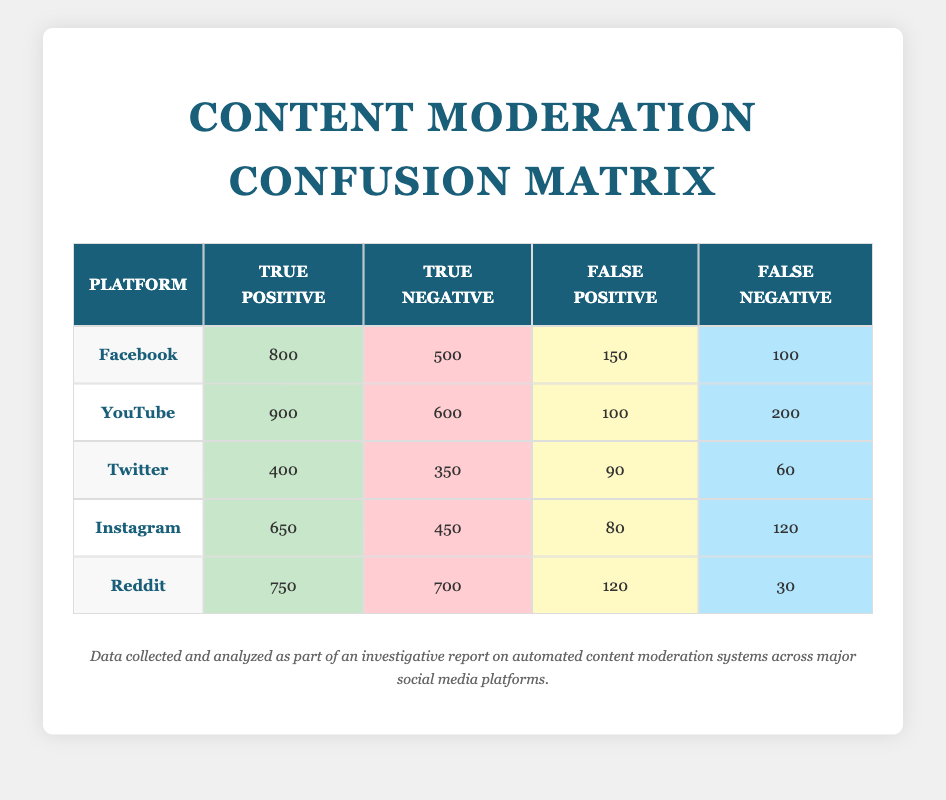What is the true positive count for YouTube? The table lists the true positive count for each platform, and for YouTube, the value is explicitly stated as 900.
Answer: 900 Which platform has the highest false negative rate? To find the false negative rate, we look at the false negative counts across all platforms. YouTube has 200, while others have lower counts (Facebook 100, Twitter 60, Instagram 120, Reddit 30). Therefore, YouTube has the highest false negative count.
Answer: YouTube What is the total number of true positives for Facebook and Instagram combined? The true positives for Facebook is 800 and for Instagram is 650. Adding these two values gives us 800 + 650 = 1450.
Answer: 1450 Is the false positive count for Twitter greater than that of Instagram? The false positive count for Twitter is 90, and for Instagram, it is 80. Since 90 > 80, the statement is true.
Answer: Yes What is the average number of true negatives across all platforms? To find the average, sum the true negatives: Facebook 500 + YouTube 600 + Twitter 350 + Instagram 450 + Reddit 700 = 2600. There are 5 platforms, so the average is 2600 / 5 = 520.
Answer: 520 Which platform has the lowest true negative count? From the table, the true negative counts are: Facebook 500, YouTube 600, Twitter 350, Instagram 450, Reddit 700. The lowest count is for Twitter at 350.
Answer: Twitter What percentage of content was falsely identified as positive on Reddit? The false positive count for Reddit is 120, and the total of true positives and false positives is 750 + 120 = 870. The percentage of false positives is (120 / 870) * 100 = approximately 13.79%.
Answer: 13.79% How many total cases were assessed by the content moderation system on Instagram? Total cases assessed can be calculated by adding true positives, true negatives, false positives, and false negatives for Instagram: 650 + 450 + 80 + 120 = 1300.
Answer: 1300 Which platform has the best ratio of true positives to false negatives? To determine this, we calculate the ratio of true positives to false negatives for each platform. For Facebook (800/100), it is 8; for YouTube (900/200), it is 4.5; for Twitter (400/60), it is approximately 6.67; for Instagram (650/120), it is approximately 5.42; for Reddit (750/30), it is 25. The best ratio is for Reddit at 25.
Answer: Reddit 